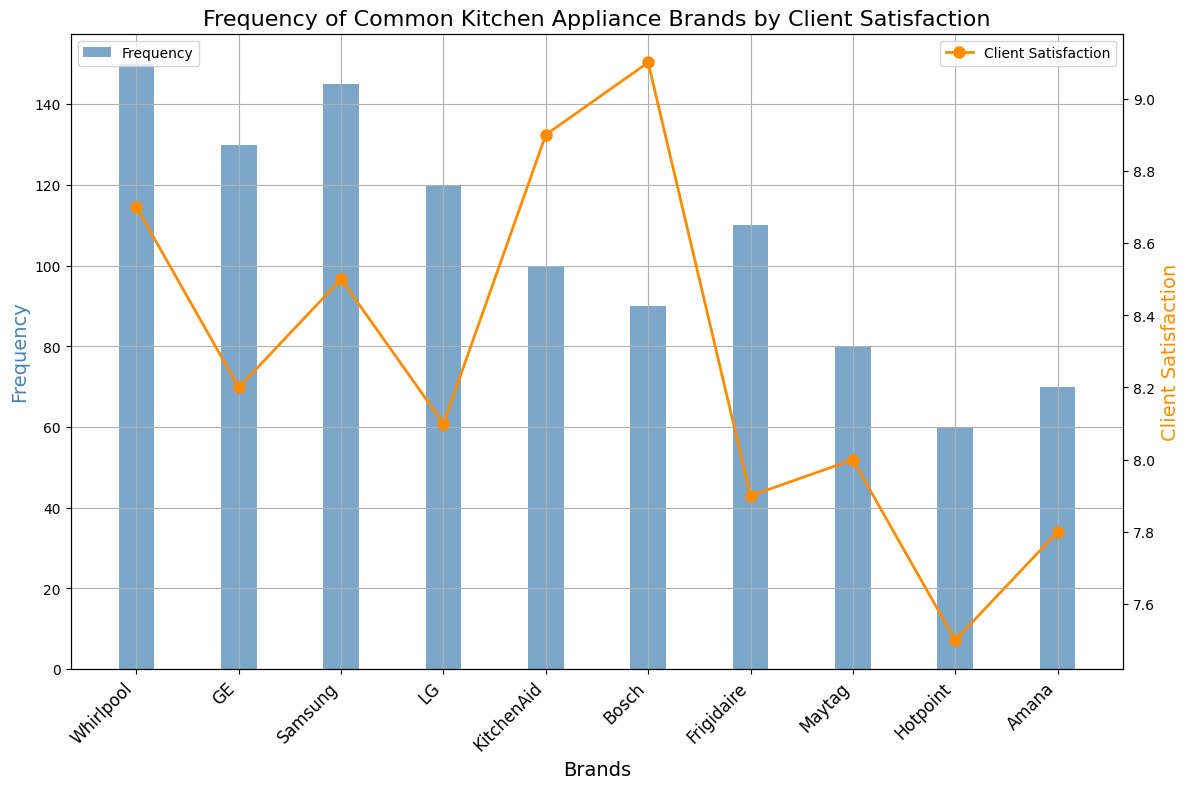Which kitchen appliance brand has the highest client satisfaction? To find the brand with the highest client satisfaction, look at the top points of the orange line (Client Satisfaction) and identify the brand directly below it on the x-axis. Bosch has the highest client satisfaction score of 9.1.
Answer: Bosch How many more Whirlpool appliances are sold compared to Hotpoint? To determine how many more Whirlpool appliances are sold compared to Hotpoint, look at the heights of the blue bars for these brands. Whirlpool has a frequency of 150, and Hotpoint has a frequency of 60. The difference is 150 - 60 = 90.
Answer: 90 Which brand has the lowest Client Satisfaction, and what is the score? To find the brand with the lowest Client Satisfaction, look at the bottommost orange point on the graph and identify the corresponding brand. Hotpoint has the lowest client satisfaction score of 7.5.
Answer: Hotpoint What is the average Client Satisfaction across all brands? Sum all Client Satisfaction scores and divide by the number of brands. The total score is 8.7 + 8.2 + 8.5 + 8.1 + 8.9 + 9.1 + 7.9 + 8.0 + 7.5 + 7.8 = 82.7. There are 10 brands, so the average is 82.7 / 10 = 8.27.
Answer: 8.27 Compare the frequencies between Samsung and GE. Which one is higher and by how much? Look at the heights of the blue bars for Samsung and GE. Samsung has a frequency of 145, and GE has a frequency of 130. Samsung's frequency is higher by 145 - 130 = 15.
Answer: Samsung, by 15 What is the median Client Satisfaction score among all brands? To find the median, list the Client Satisfaction scores in ascending order: 7.5, 7.8, 7.9, 8.0, 8.1, 8.2, 8.5, 8.7, 8.9, 9.1. Since there are 10 data points, the median will be the average of the 5th and 6th scores: (8.1 + 8.2) / 2 = 8.15.
Answer: 8.15 Which brand has a higher frequency: LG or Maytag? Compare the heights of the blue bars for LG and Maytag. LG has a frequency of 120, and Maytag has a frequency of 80. LG has a higher frequency.
Answer: LG What pattern do you observe between frequency and client satisfaction among the brands? Generally, brands with higher frequencies (more popular brands) tend to have high client satisfaction, although this is not a strict rule. For instance, Whirlpool and Samsung both have high frequencies and also high satisfaction scores above 8. On the other hand, even some brands with lower frequencies like Bosch have high satisfaction scores.
Answer: High frequency often correlates with high satisfaction but not always Which two brands have the closest client satisfaction scores? To find the closest scores, compare the client satisfaction numbers. LG (8.1) and GE (8.2) have the closest scores, with a difference of only 0.1.
Answer: LG and GE, 0.1 